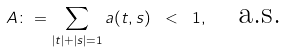Convert formula to latex. <formula><loc_0><loc_0><loc_500><loc_500>A \colon = \sum _ { | t | + | s | = 1 } a ( t , s ) \ < \ 1 , \quad \text {a.s.}</formula> 